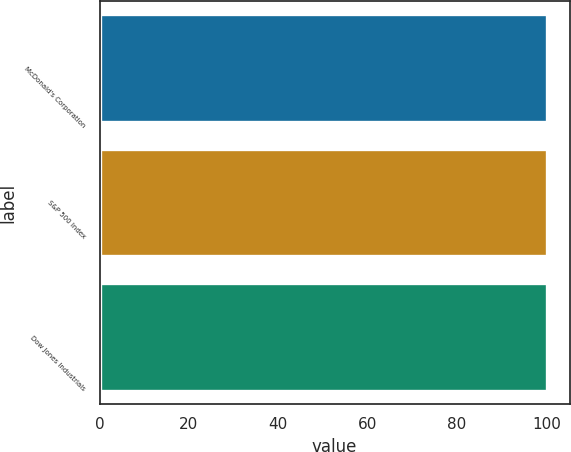Convert chart to OTSL. <chart><loc_0><loc_0><loc_500><loc_500><bar_chart><fcel>McDonald's Corporation<fcel>S&P 500 Index<fcel>Dow Jones Industrials<nl><fcel>100<fcel>100.1<fcel>100.2<nl></chart> 